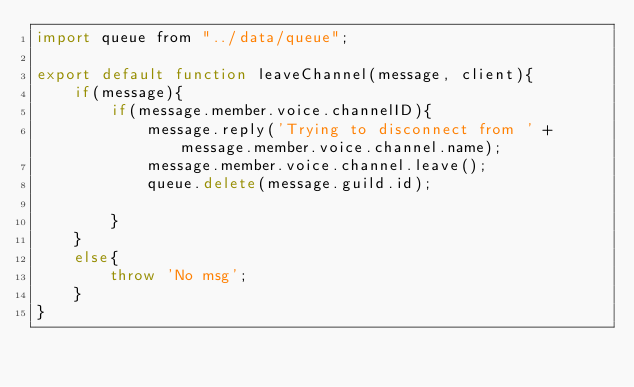<code> <loc_0><loc_0><loc_500><loc_500><_JavaScript_>import queue from "../data/queue";

export default function leaveChannel(message, client){
    if(message){
        if(message.member.voice.channelID){
            message.reply('Trying to disconnect from ' + message.member.voice.channel.name);
            message.member.voice.channel.leave();
            queue.delete(message.guild.id);

        }
    }
    else{
        throw 'No msg';
    }
}</code> 